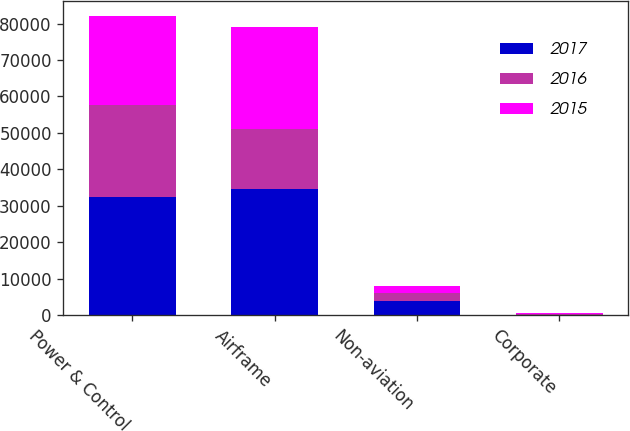<chart> <loc_0><loc_0><loc_500><loc_500><stacked_bar_chart><ecel><fcel>Power & Control<fcel>Airframe<fcel>Non-aviation<fcel>Corporate<nl><fcel>2017<fcel>32424<fcel>34526<fcel>3981<fcel>82<nl><fcel>2016<fcel>25120<fcel>16498<fcel>2169<fcel>195<nl><fcel>2015<fcel>24664<fcel>28086<fcel>1889<fcel>232<nl></chart> 